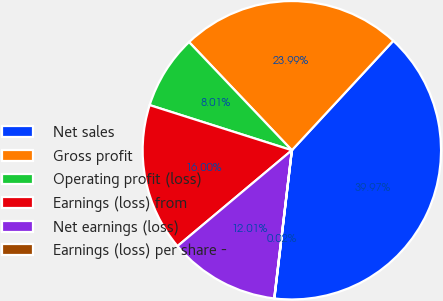Convert chart. <chart><loc_0><loc_0><loc_500><loc_500><pie_chart><fcel>Net sales<fcel>Gross profit<fcel>Operating profit (loss)<fcel>Earnings (loss) from<fcel>Net earnings (loss)<fcel>Earnings (loss) per share -<nl><fcel>39.97%<fcel>23.99%<fcel>8.01%<fcel>16.0%<fcel>12.01%<fcel>0.02%<nl></chart> 